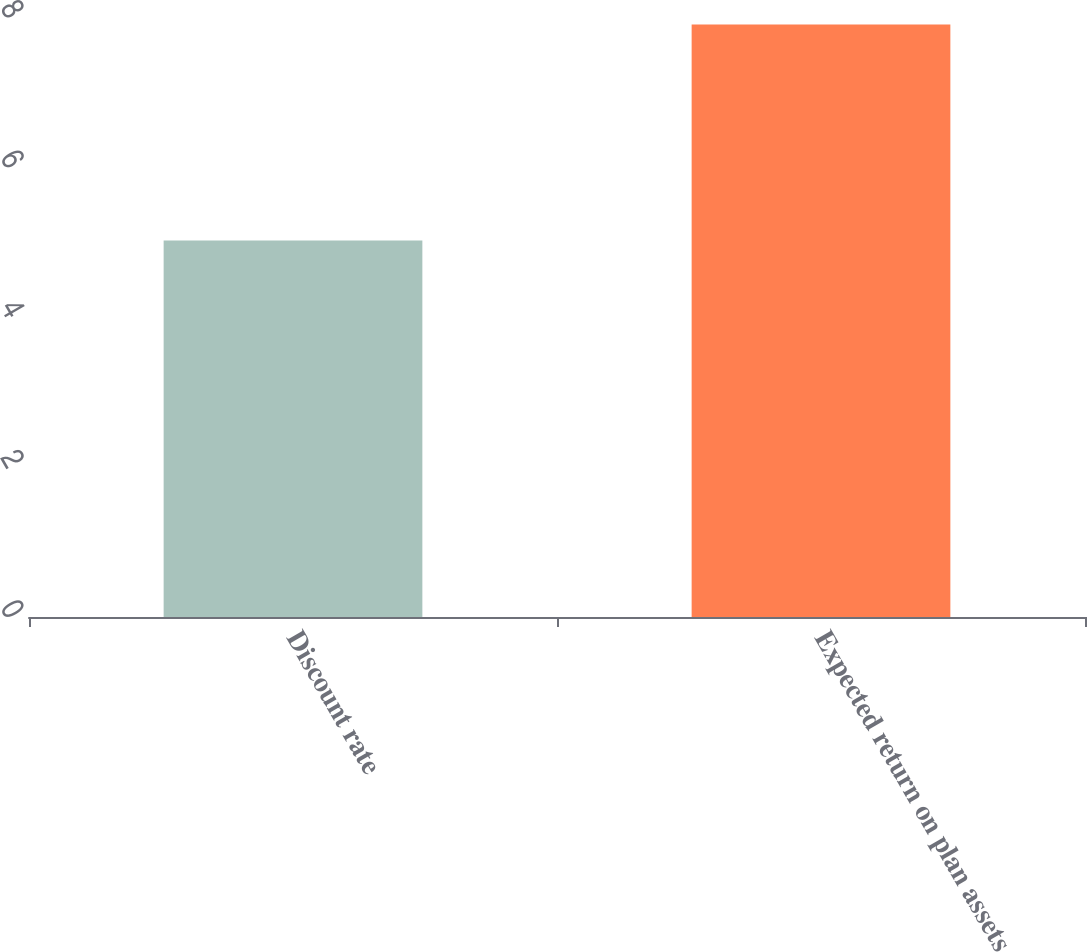Convert chart to OTSL. <chart><loc_0><loc_0><loc_500><loc_500><bar_chart><fcel>Discount rate<fcel>Expected return on plan assets<nl><fcel>5.02<fcel>7.9<nl></chart> 